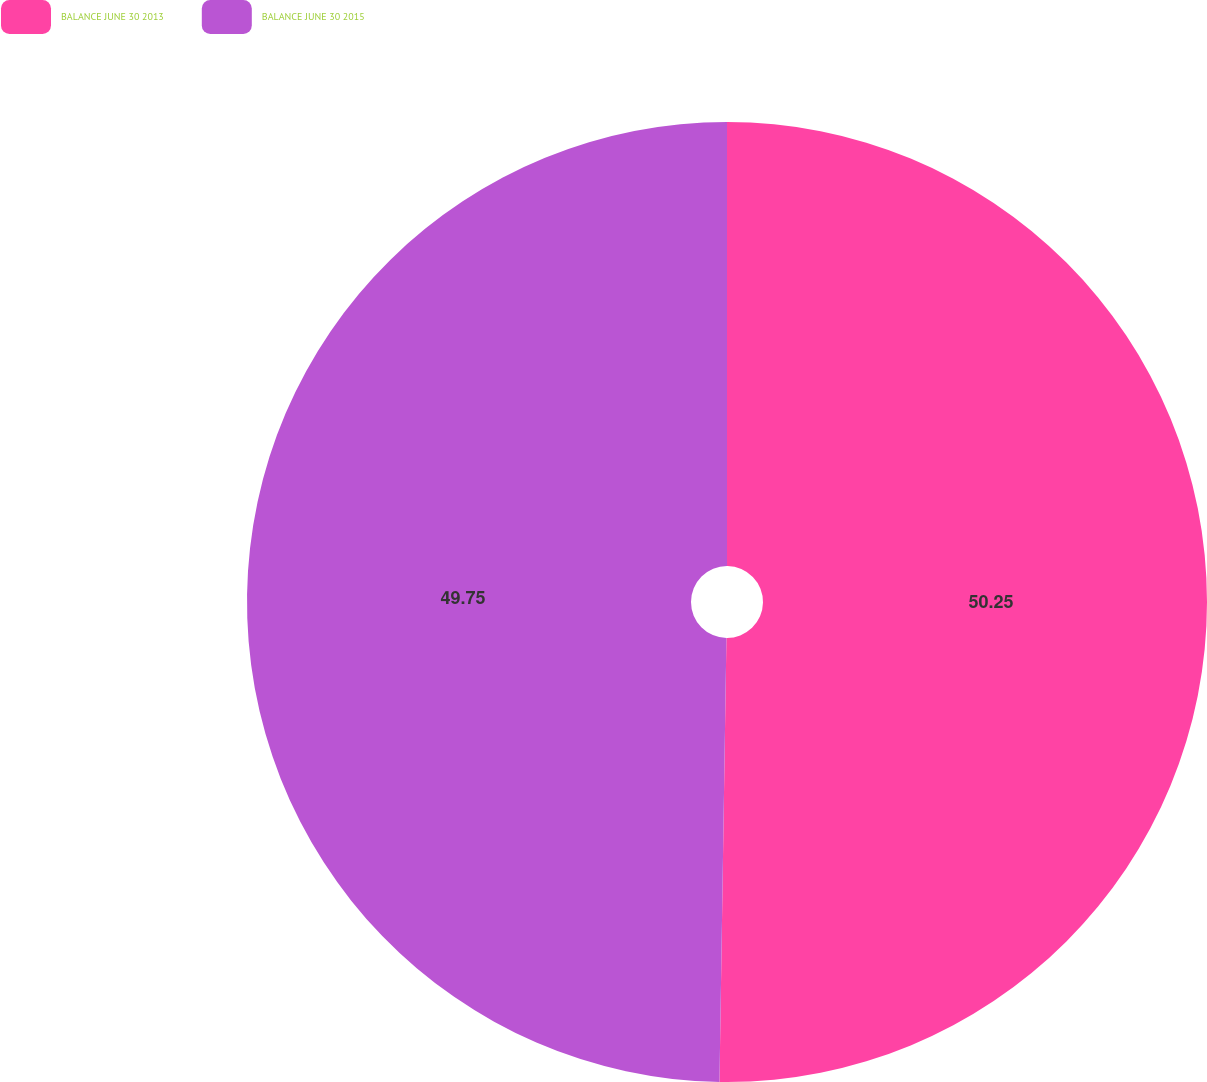Convert chart to OTSL. <chart><loc_0><loc_0><loc_500><loc_500><pie_chart><fcel>BALANCE JUNE 30 2013<fcel>BALANCE JUNE 30 2015<nl><fcel>50.25%<fcel>49.75%<nl></chart> 